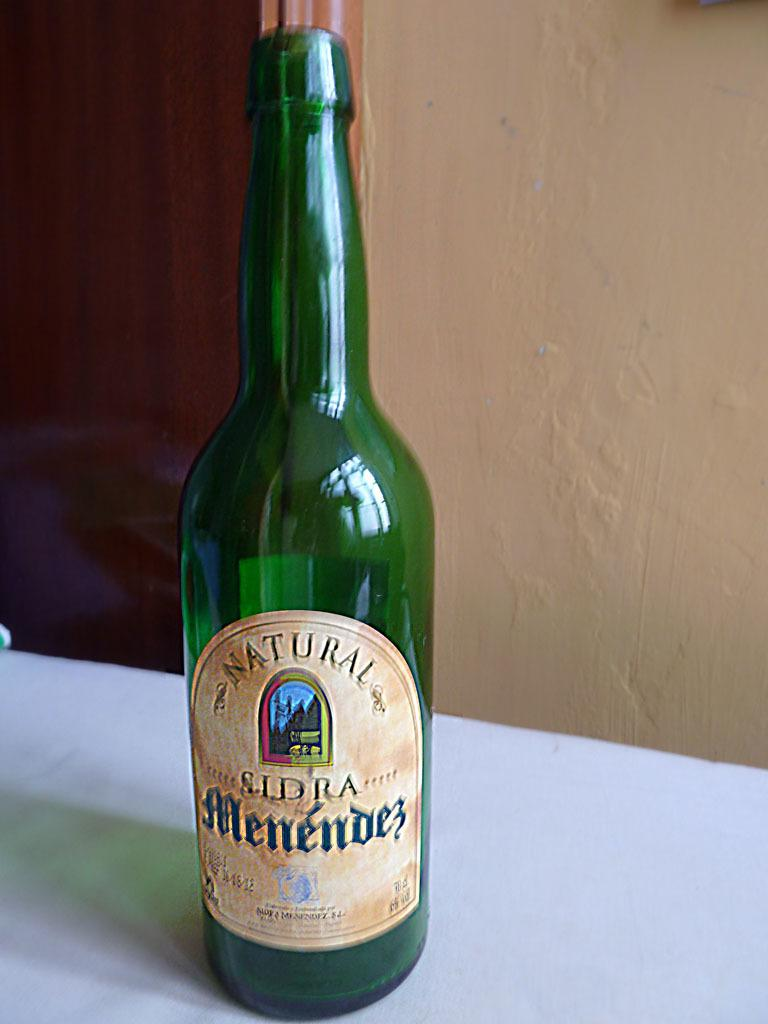<image>
Write a terse but informative summary of the picture. A green bottle that says natural and is menendez. 